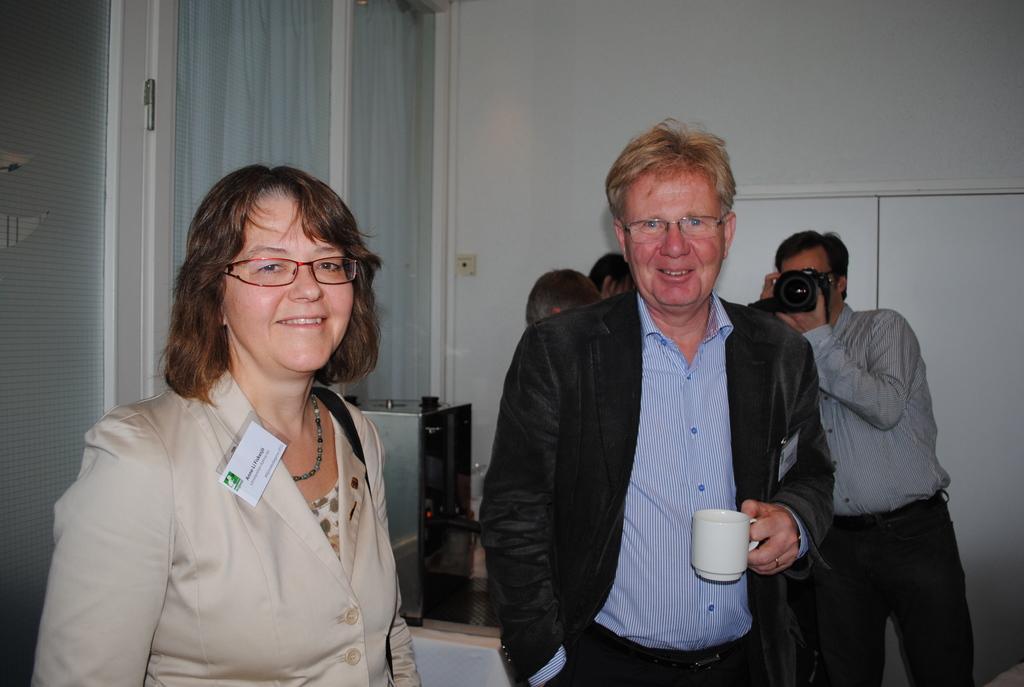Can you describe this image briefly? In this image, there is a person standing and wearing clothes. These two person are wearing spectacles on their head. There is person taking a snap with a camera. This person is holding a cup with his hands. There is a machine behind this person. There is a window attached to the wall. This wall is behind These persons. 